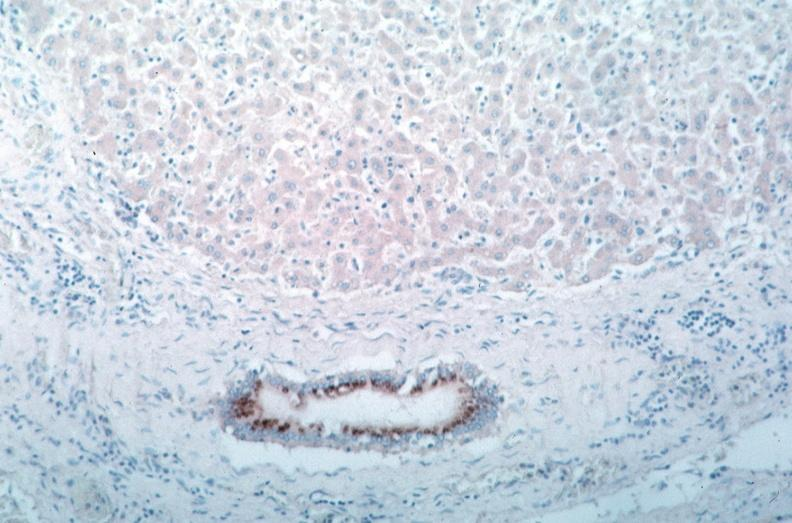what spotted fever , immunoperoxidase staining vessels for rickettsia rickettsii?
Answer the question using a single word or phrase. Vasculitis rocky mountain 